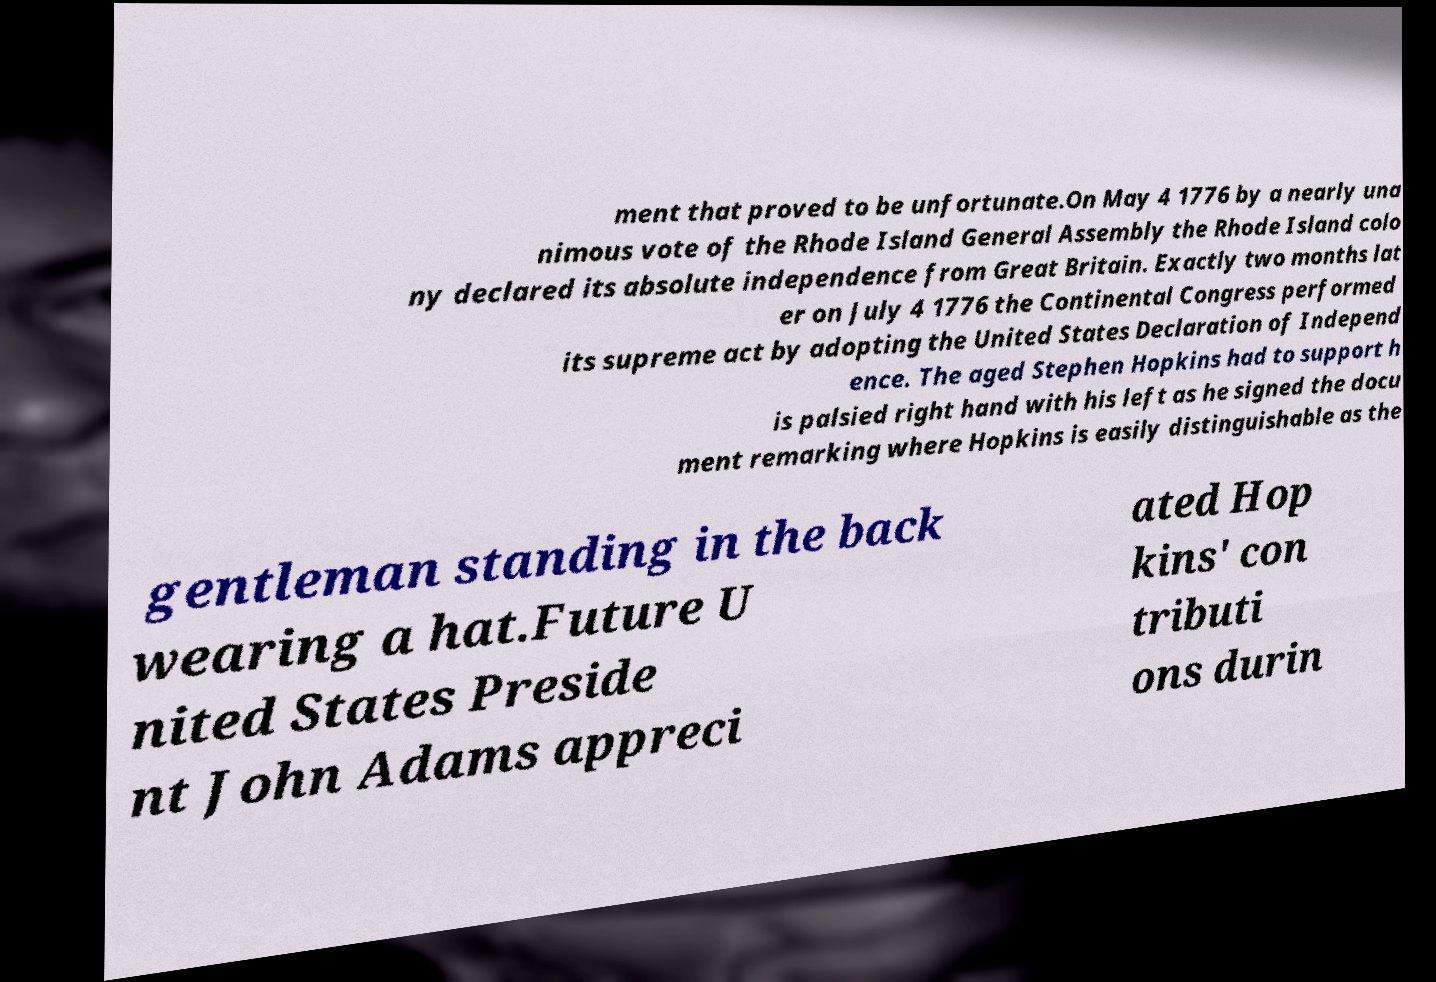There's text embedded in this image that I need extracted. Can you transcribe it verbatim? ment that proved to be unfortunate.On May 4 1776 by a nearly una nimous vote of the Rhode Island General Assembly the Rhode Island colo ny declared its absolute independence from Great Britain. Exactly two months lat er on July 4 1776 the Continental Congress performed its supreme act by adopting the United States Declaration of Independ ence. The aged Stephen Hopkins had to support h is palsied right hand with his left as he signed the docu ment remarking where Hopkins is easily distinguishable as the gentleman standing in the back wearing a hat.Future U nited States Preside nt John Adams appreci ated Hop kins' con tributi ons durin 